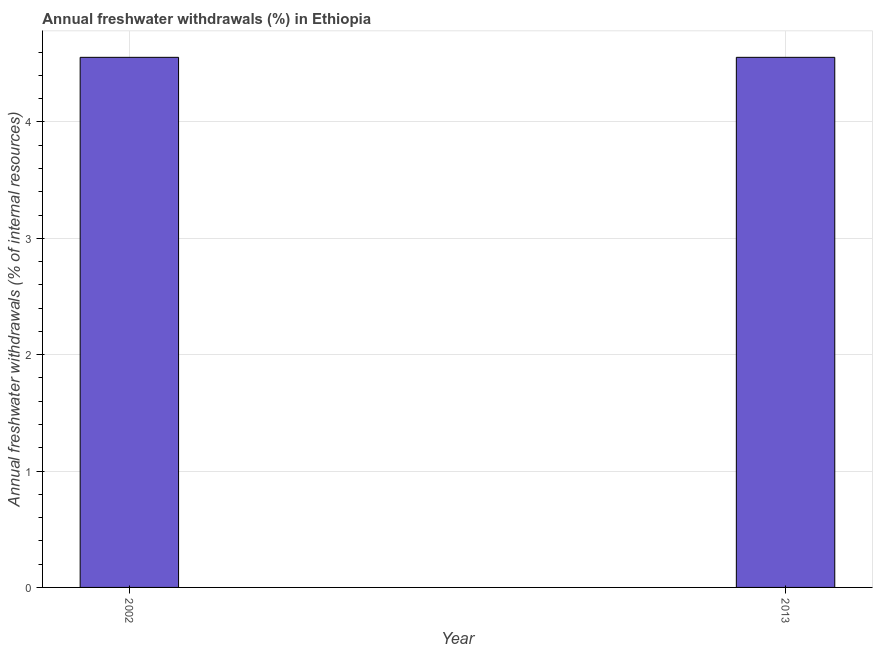Does the graph contain any zero values?
Provide a short and direct response. No. Does the graph contain grids?
Keep it short and to the point. Yes. What is the title of the graph?
Offer a terse response. Annual freshwater withdrawals (%) in Ethiopia. What is the label or title of the Y-axis?
Give a very brief answer. Annual freshwater withdrawals (% of internal resources). What is the annual freshwater withdrawals in 2013?
Provide a short and direct response. 4.56. Across all years, what is the maximum annual freshwater withdrawals?
Your answer should be compact. 4.56. Across all years, what is the minimum annual freshwater withdrawals?
Your response must be concise. 4.56. In which year was the annual freshwater withdrawals maximum?
Offer a very short reply. 2002. In which year was the annual freshwater withdrawals minimum?
Ensure brevity in your answer.  2002. What is the sum of the annual freshwater withdrawals?
Keep it short and to the point. 9.11. What is the average annual freshwater withdrawals per year?
Ensure brevity in your answer.  4.56. What is the median annual freshwater withdrawals?
Provide a succinct answer. 4.56. In how many years, is the annual freshwater withdrawals greater than 3.2 %?
Provide a short and direct response. 2. Do a majority of the years between 2002 and 2013 (inclusive) have annual freshwater withdrawals greater than 0.8 %?
Your answer should be compact. Yes. What is the ratio of the annual freshwater withdrawals in 2002 to that in 2013?
Provide a short and direct response. 1. Is the annual freshwater withdrawals in 2002 less than that in 2013?
Keep it short and to the point. No. How many bars are there?
Provide a succinct answer. 2. What is the Annual freshwater withdrawals (% of internal resources) of 2002?
Your answer should be compact. 4.56. What is the Annual freshwater withdrawals (% of internal resources) of 2013?
Ensure brevity in your answer.  4.56. What is the difference between the Annual freshwater withdrawals (% of internal resources) in 2002 and 2013?
Give a very brief answer. 0. 